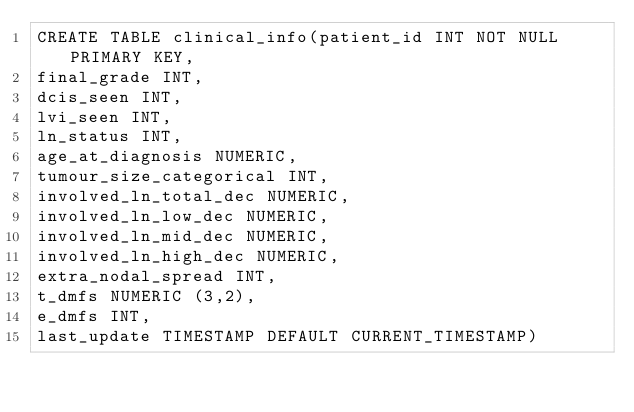<code> <loc_0><loc_0><loc_500><loc_500><_SQL_>CREATE TABLE clinical_info(patient_id INT NOT NULL PRIMARY KEY,
final_grade INT,
dcis_seen INT,
lvi_seen INT,
ln_status INT,
age_at_diagnosis NUMERIC,
tumour_size_categorical INT,
involved_ln_total_dec NUMERIC,
involved_ln_low_dec NUMERIC,
involved_ln_mid_dec NUMERIC,
involved_ln_high_dec NUMERIC,
extra_nodal_spread INT,
t_dmfs NUMERIC (3,2),
e_dmfs INT,
last_update TIMESTAMP DEFAULT CURRENT_TIMESTAMP)</code> 